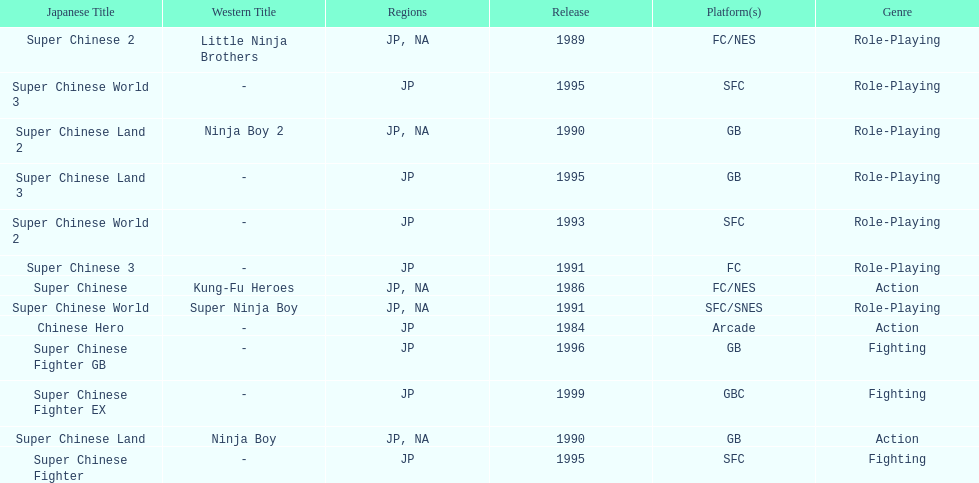What are the total of super chinese games released? 13. 